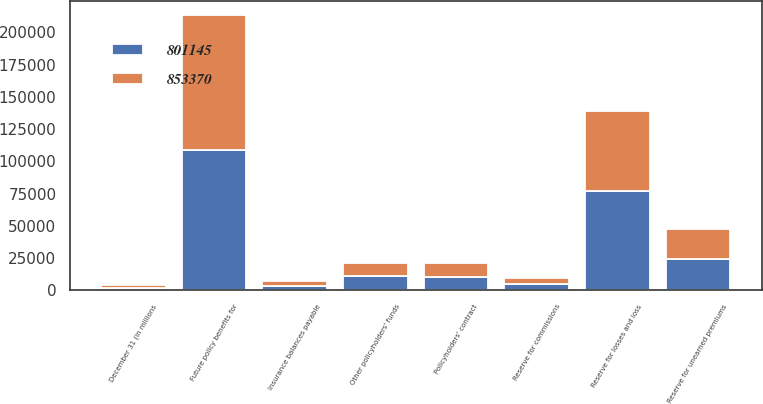<chart> <loc_0><loc_0><loc_500><loc_500><stacked_bar_chart><ecel><fcel>December 31 (in millions<fcel>Reserve for losses and loss<fcel>Reserve for unearned premiums<fcel>Future policy benefits for<fcel>Policyholders' contract<fcel>Other policyholders' funds<fcel>Reserve for commissions<fcel>Insurance balances payable<nl><fcel>801145<fcel>2005<fcel>77169<fcel>24243<fcel>108807<fcel>10575<fcel>10870<fcel>4769<fcel>3564<nl><fcel>853370<fcel>2004<fcel>61878<fcel>23400<fcel>104740<fcel>10575<fcel>10280<fcel>4629<fcel>3661<nl></chart> 